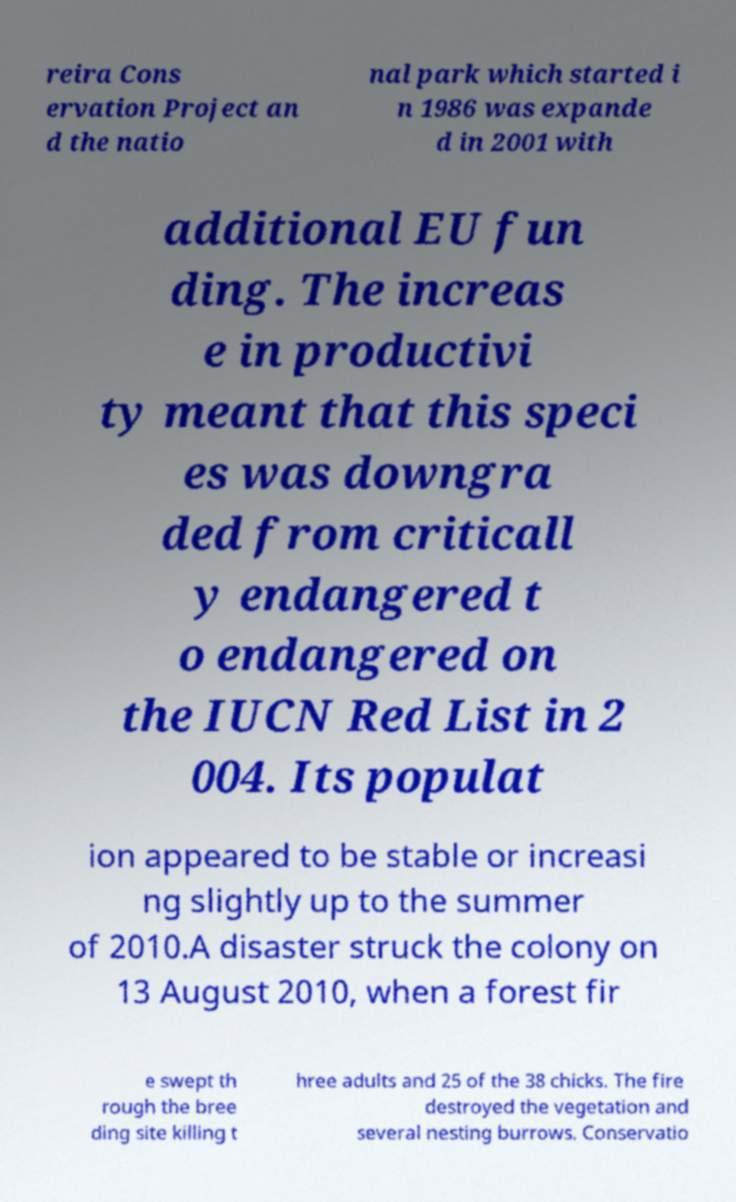There's text embedded in this image that I need extracted. Can you transcribe it verbatim? reira Cons ervation Project an d the natio nal park which started i n 1986 was expande d in 2001 with additional EU fun ding. The increas e in productivi ty meant that this speci es was downgra ded from criticall y endangered t o endangered on the IUCN Red List in 2 004. Its populat ion appeared to be stable or increasi ng slightly up to the summer of 2010.A disaster struck the colony on 13 August 2010, when a forest fir e swept th rough the bree ding site killing t hree adults and 25 of the 38 chicks. The fire destroyed the vegetation and several nesting burrows. Conservatio 